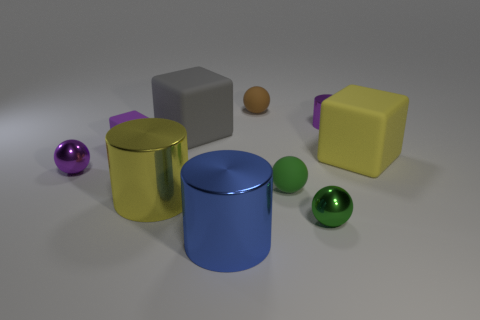How many large gray things are behind the small purple cylinder?
Provide a succinct answer. 0. Do the purple block and the yellow thing to the right of the brown rubber sphere have the same material?
Your answer should be very brief. Yes. Is there a yellow thing of the same size as the yellow metallic cylinder?
Your answer should be compact. Yes. Are there an equal number of small purple matte cubes that are behind the big gray matte object and tiny green rubber balls?
Keep it short and to the point. No. How big is the yellow metallic thing?
Your answer should be compact. Large. What number of brown objects are in front of the green ball that is behind the large yellow cylinder?
Offer a very short reply. 0. The tiny rubber thing that is to the right of the large yellow metallic cylinder and in front of the brown matte ball has what shape?
Your answer should be compact. Sphere. How many big blocks have the same color as the tiny rubber cube?
Provide a succinct answer. 0. There is a big yellow thing in front of the big yellow thing right of the big blue cylinder; are there any objects that are behind it?
Offer a very short reply. Yes. What is the size of the purple thing that is both behind the small purple sphere and on the left side of the big gray thing?
Give a very brief answer. Small. 